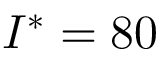<formula> <loc_0><loc_0><loc_500><loc_500>I ^ { * } = 8 0</formula> 